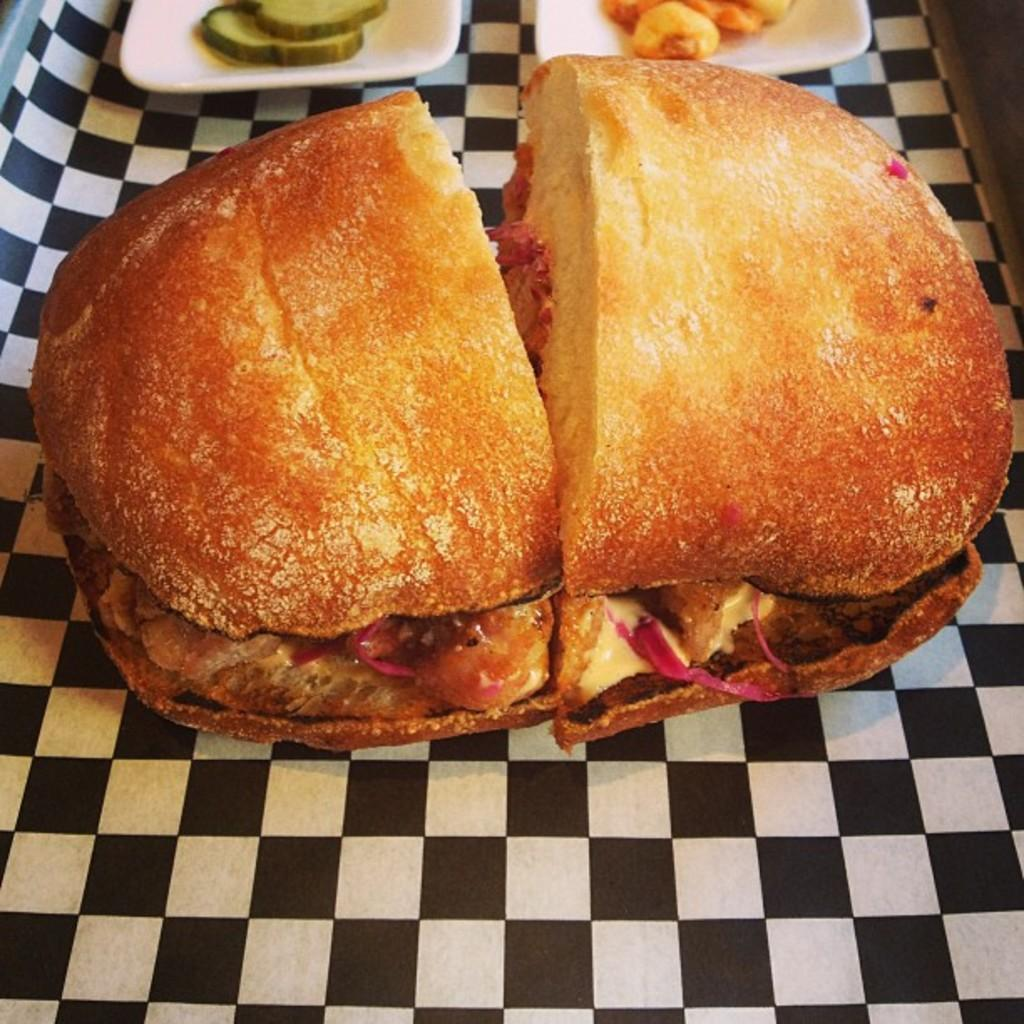What is the main subject of the image? There is a food item in the image. Can you describe the other food items in the image? There are other food items on plates in the image. What is the color scheme of the surface the plates are on? The surface the plates are on is black and white colored. What type of waves can be seen crashing on the shore in the image? There are no waves or shore visible in the image; it features food items on plates. What flavor of food can be tasted in the image? The image does not convey the flavor of the food; it only shows the appearance of the food items. 